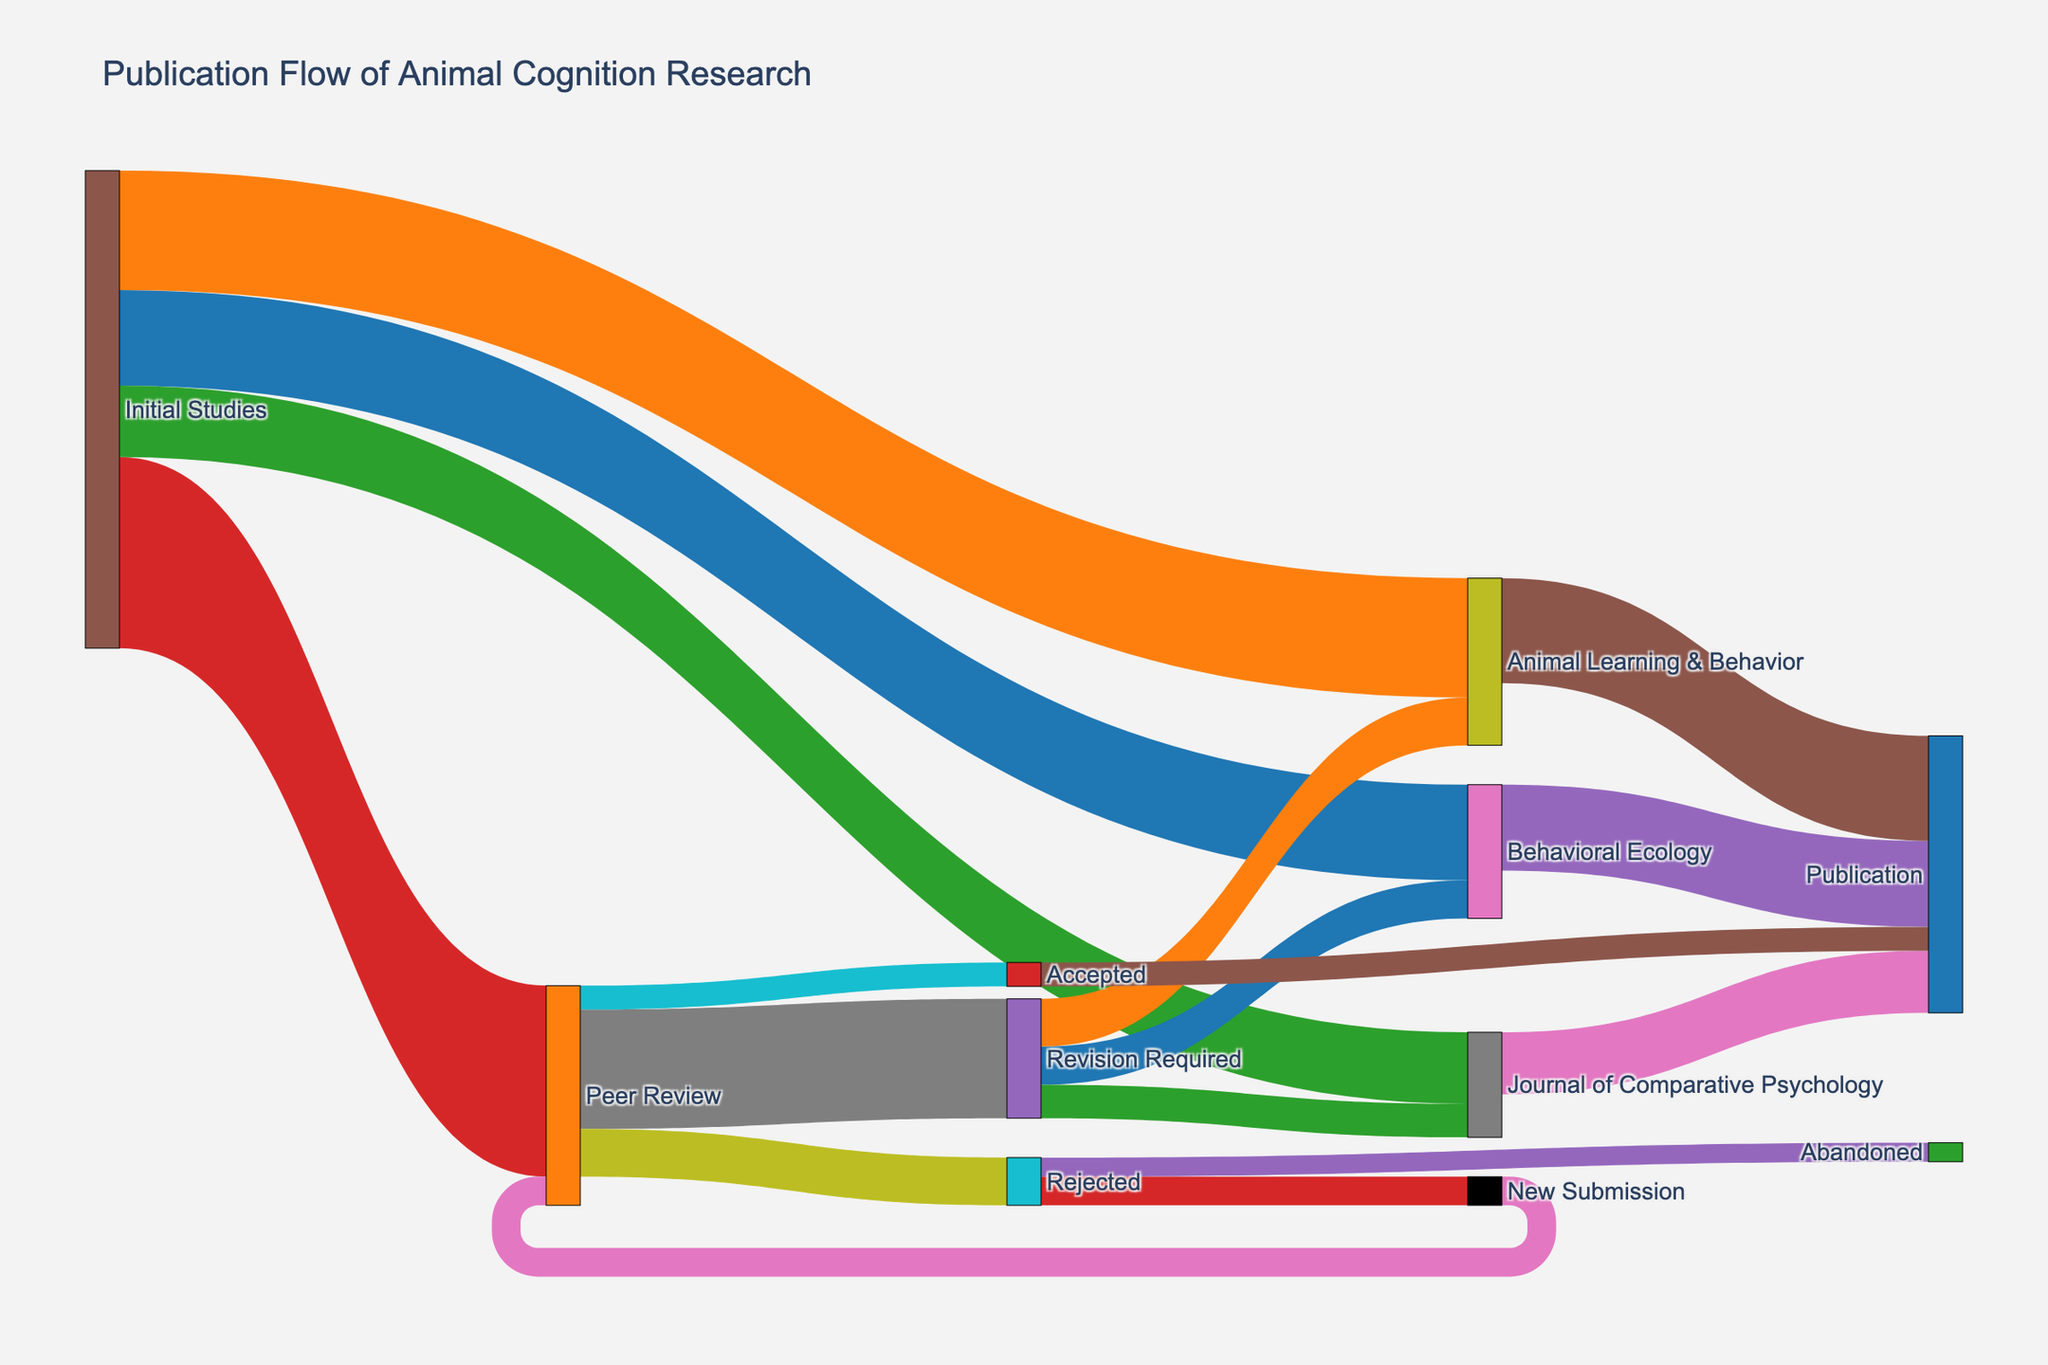how many initial studies flow into the peer review stage? Look at the flow from "Initial Studies" to "Peer Review" in the diagram. The value associated with this flow is 40.
Answer: 40 Which publication destination receives the most studies directly from initial studies? Compare the values connected from "Initial Studies" to the different publication destinations ("Behavioral Ecology," "Animal Learning & Behavior," and "Journal of Comparative Psychology"). The highest value is found for "Animal Learning & Behavior" with 25 studies.
Answer: Animal Learning & Behavior What is the total number of studies that end up published? Sum the values flowing into "Publication" from all sources (18 from "Behavioral Ecology," 22 from "Animal Learning & Behavior," 13 from "Journal of Comparative Psychology," and 5 from "Accepted"). The total number is 18 + 22 + 13 + 5 = 58.
Answer: 58 How many studies require revision after peer review compared to those accepted without revision? Compare the values flowing from "Peer Review" to "Revision Required" and "Accepted." "Revision Required" is 25, and "Accepted" is 5.
Answer: 25 require revision, 5 accepted what's the probability of a study getting accepted without needing revision after peer review? Calculate the probability by dividing the number of studies accepted without revision by the total number of studies reviewed. There are 5 studies accepted without revision out of 40 peer-reviewed studies, so the probability is 5/40 = 0.125 or 12.5%.
Answer: 12.5% which outcome has a higher number of studies: revised and then published or new submission after rejection? Compare the sum of revisions leading to publication (8 to "Behavioral Ecology," 10 to "Animal Learning & Behavior," and 7 to "Journal of Comparative Psychology," totaling 25) against the new submissions after rejection (6 leading to "Peer Review"). 25 studies are revised and published, while 6 are new submissions.
Answer: Revised and published How many studies get abandoned after rejection? Find the value associated with the flow from "Rejected" to "Abandoned." This value is 4.
Answer: 4 